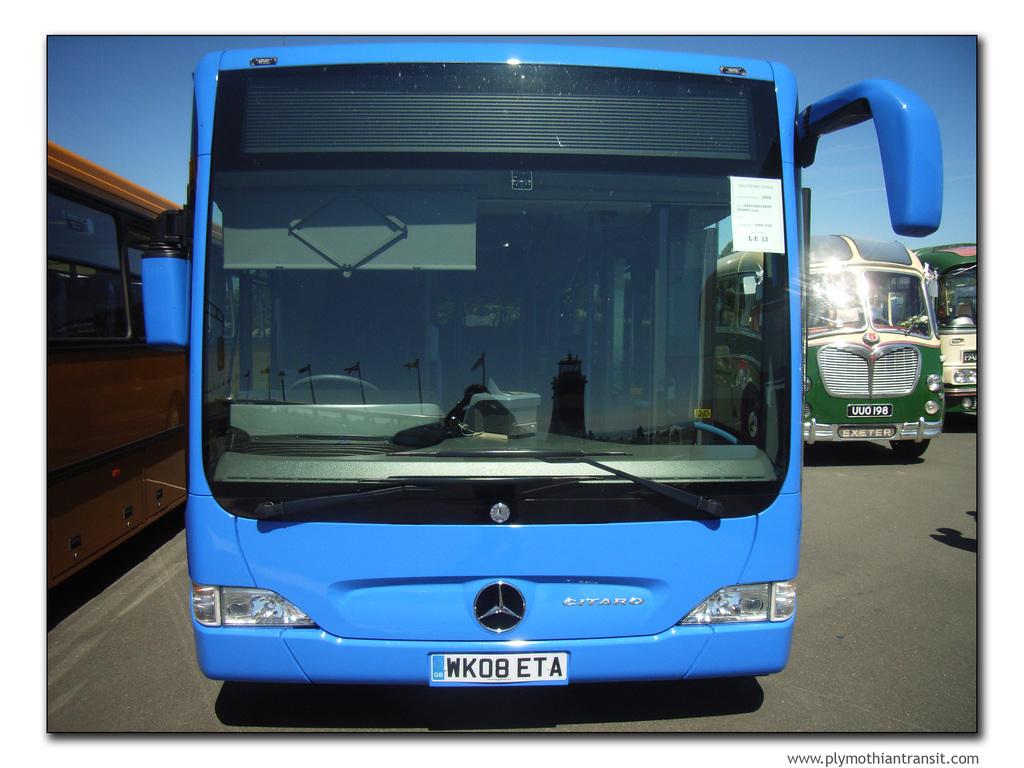Who makes this bus?
Your response must be concise. Mercedes. What is the tag number?
Your answer should be very brief. Wkob eta. 